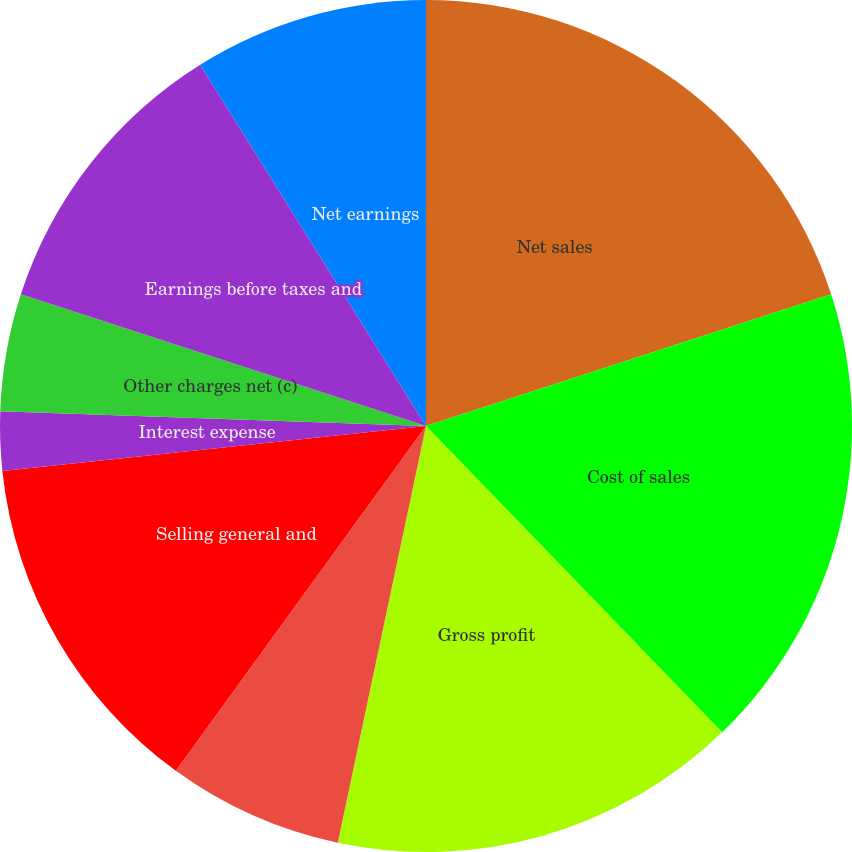Convert chart to OTSL. <chart><loc_0><loc_0><loc_500><loc_500><pie_chart><fcel>Net sales<fcel>Cost of sales<fcel>Gross profit<fcel>Research and development<fcel>Selling general and<fcel>Amortization (b)<fcel>Interest expense<fcel>Other charges net (c)<fcel>Earnings before taxes and<fcel>Net earnings<nl><fcel>20.0%<fcel>17.77%<fcel>15.55%<fcel>6.67%<fcel>13.33%<fcel>0.0%<fcel>2.23%<fcel>4.45%<fcel>11.11%<fcel>8.89%<nl></chart> 